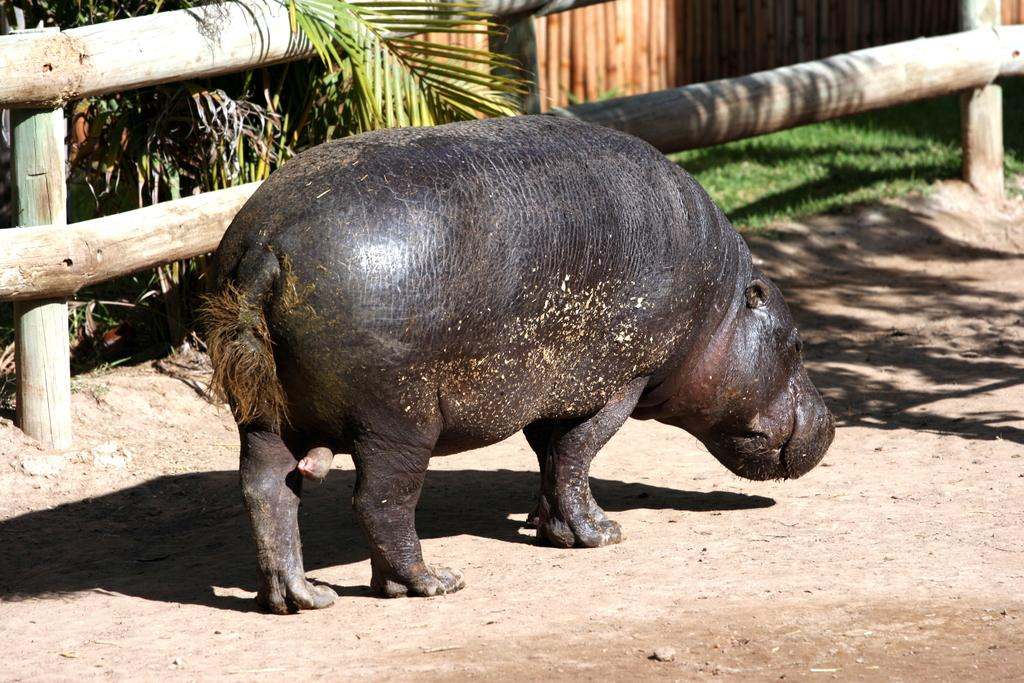What animal is on the ground in the image? There is a hippopotamus on the ground in the image. What type of fencing can be seen at the top of the image? Wooden fences are visible at the top of the image. What other elements can be seen at the top of the image? Plants and grass are present at the top of the image. What is the hippopotamus hoping for in the image? The image does not provide information about the hippopotamus's hopes or emotions, so we cannot determine what it might be hoping for. 